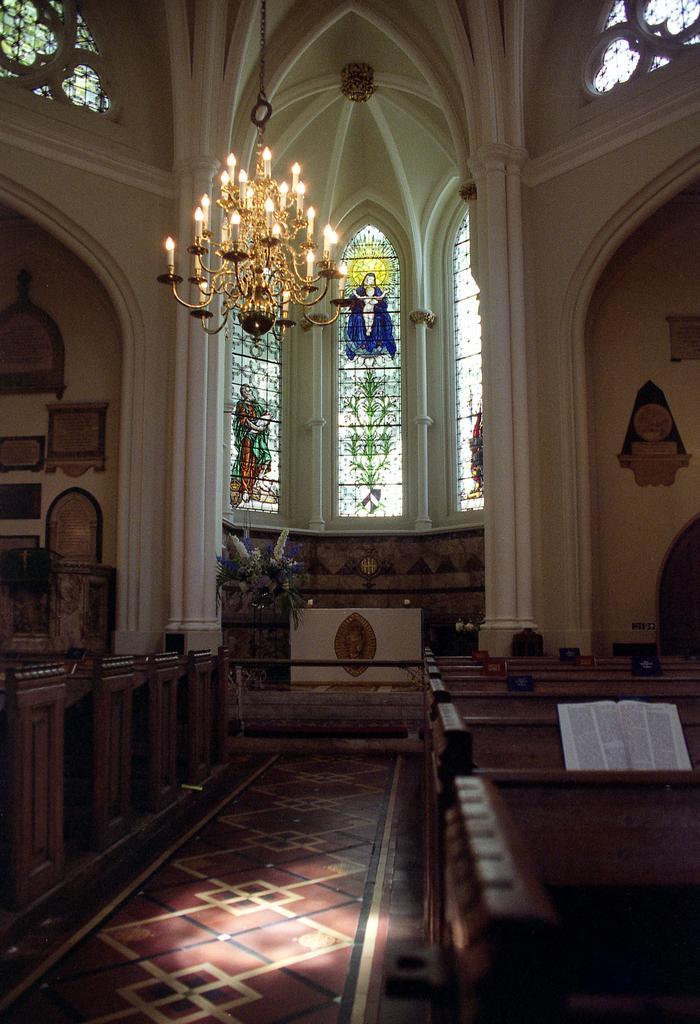In one or two sentences, can you explain what this image depicts? This is the inner view of a room. At the top part of the image we can see chandelier, windows and poles. At the bottom of the image we can see wall hangings, benches, house plant, podium and a carpet. 